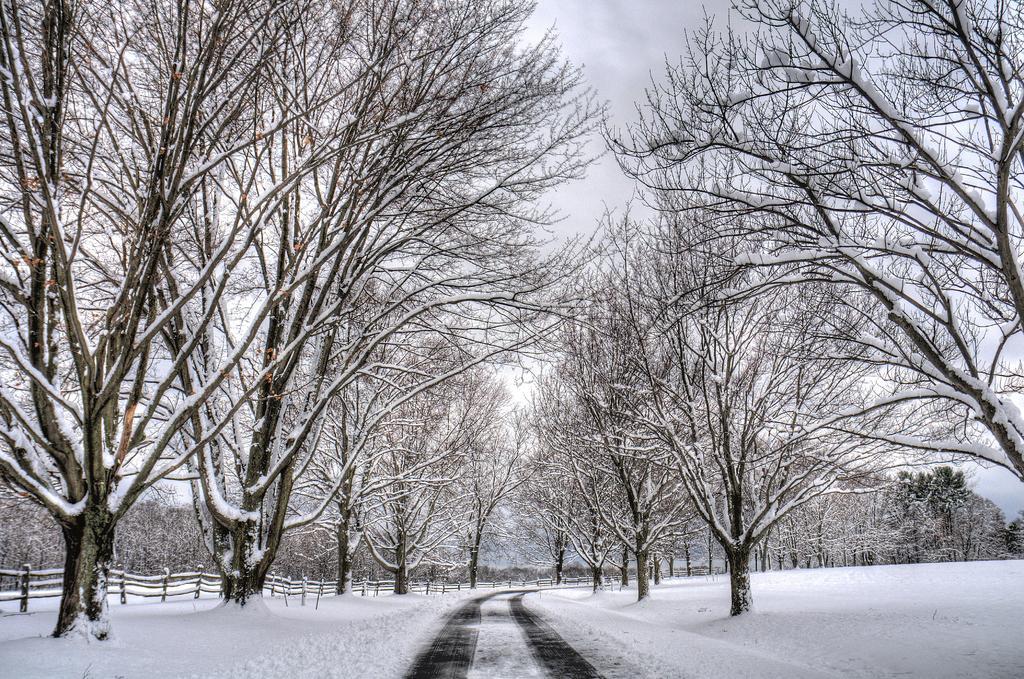Could you give a brief overview of what you see in this image? In this picture we can see trees, at the bottom there is snow, on the left side we can see fencing, there is the sky at the top of the picture. 